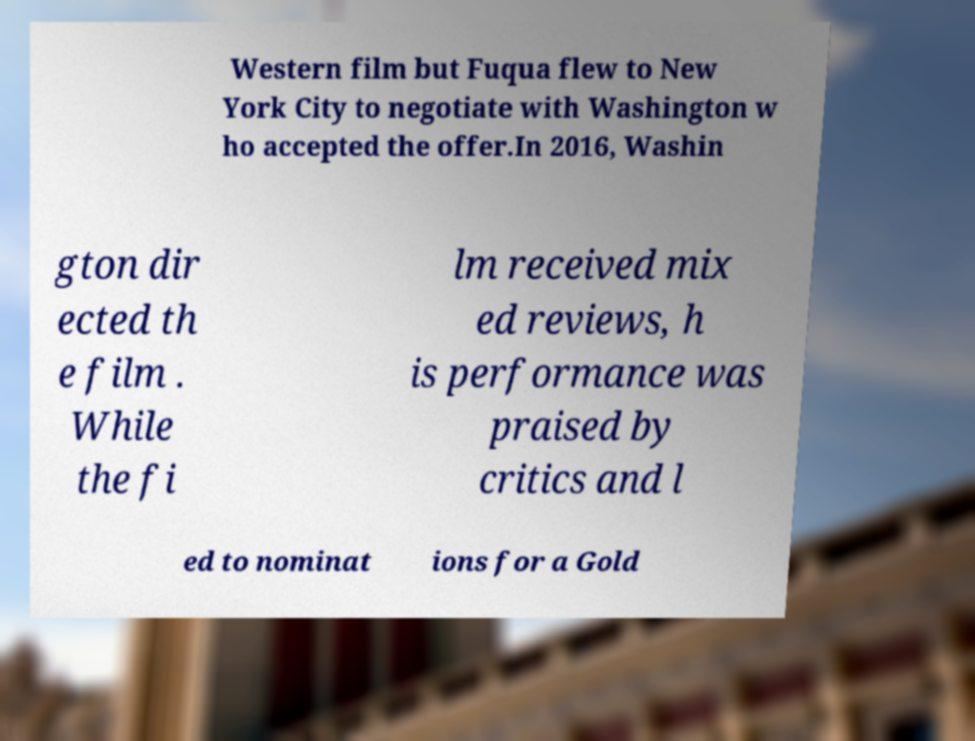Can you accurately transcribe the text from the provided image for me? Western film but Fuqua flew to New York City to negotiate with Washington w ho accepted the offer.In 2016, Washin gton dir ected th e film . While the fi lm received mix ed reviews, h is performance was praised by critics and l ed to nominat ions for a Gold 